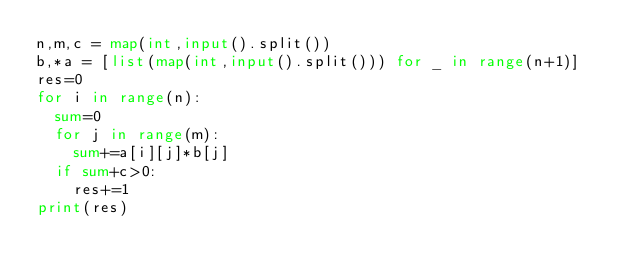Convert code to text. <code><loc_0><loc_0><loc_500><loc_500><_Python_>n,m,c = map(int,input().split())
b,*a = [list(map(int,input().split())) for _ in range(n+1)]
res=0
for i in range(n):
  sum=0
  for j in range(m):
    sum+=a[i][j]*b[j]
  if sum+c>0:
    res+=1
print(res)</code> 